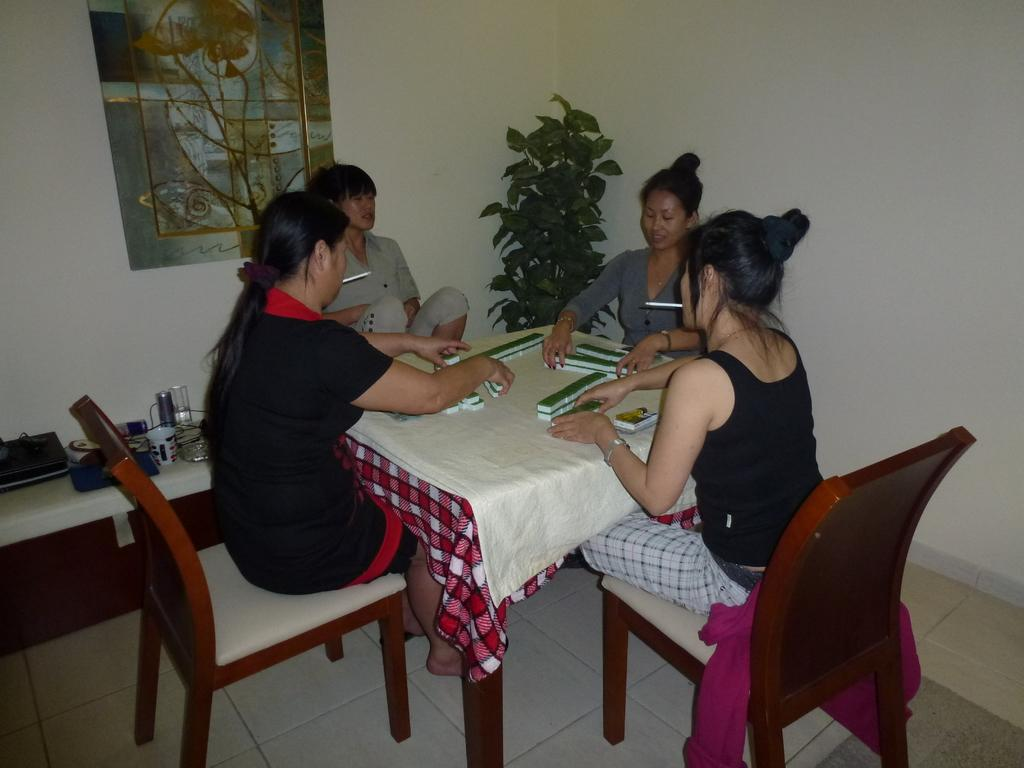What is the color of the wall in the image? The wall in the image is white. What can be seen hanging on the wall? There is a photo frame in the image. What type of plant is present in the image? There is a plant in the image. What are the people in the image doing? The people are sitting on chairs in the image. What piece of furniture is present in the image? There is a table in the image. What objects can be seen on the table? There are glasses on the table in the image. Can you tell me how many potatoes are on the table in the image? There are no potatoes present in the image. What suggestion is being made by the people sitting on chairs in the image? The image does not provide any information about a suggestion being made by the people sitting on chairs. 